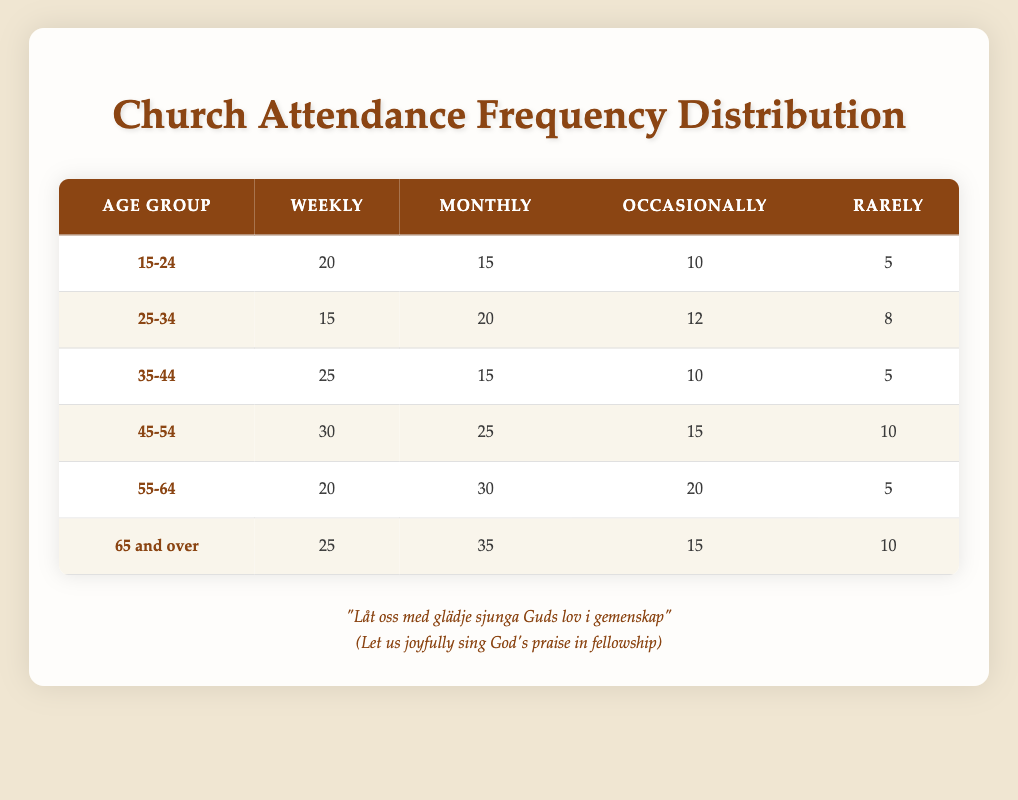What is the attendance frequency for the age group 25-34 labeled as "rarely"? In the table, under the age group 25-34, the "rarely" attendance is indicated as 8.
Answer: 8 Which age group has the highest number of weekly attendances? By comparing the values in the "weekly" column, the age group 45-54 has 30, which is the highest among all age groups.
Answer: 45-54 What is the total monthly attendance for the age group 65 and over? In the table, the "monthly" attendance for the age group 65 and over is specified as 35.
Answer: 35 Is it true that the age group 35-44 has more monthly attendees than the age group 15-24? The age group 35-44 has 15 in the "monthly" column and the age group 15-24 has 15 as well, so they are equal, resulting in a "no" answer.
Answer: No What is the combined total of occasional attendees between age groups 45-54 and 55-64? To find this, look at the "occasionally" column for both groups: 45-54 has 15 and 55-64 has 20. Adding these gives a total of 15 + 20 = 35.
Answer: 35 How many more people attend church weekly in the age group 45-54 compared to the age group 25-34? The "weekly" attendance for age group 45-54 is 30, while for age group 25-34, it is 15. The difference is 30 - 15 = 15.
Answer: 15 What is the average number of weekly attendees across all age groups? To find the average weekly attendance: Add all values in the "weekly" column (20 + 15 + 25 + 30 + 20 + 25 = 135) and divide by the number of age groups (6), which gives 135 / 6 = 22.5.
Answer: 22.5 Which age group has the highest total attendance across all categories? To determine this, sum the values for each age group: 15-24 = 20 + 15 + 10 + 5 = 50; 25-34 = 15 + 20 + 12 + 8 = 55; 35-44 = 25 + 15 + 10 + 5 = 55; 45-54 = 30 + 25 + 15 + 10 = 80; 55-64 = 20 + 30 + 20 + 5 = 75; 65 and over = 25 + 35 + 15 + 10 = 85. The highest total is for age group 65 and over at 85.
Answer: 65 and over 